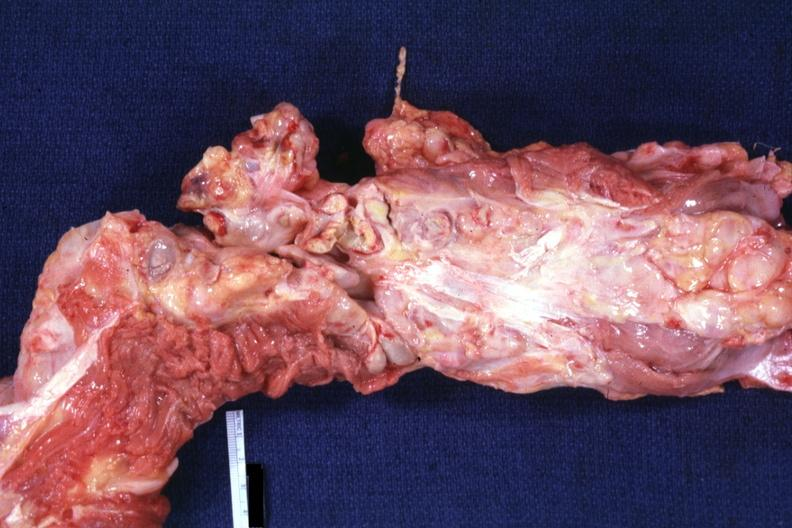s hodgkins disease present?
Answer the question using a single word or phrase. Yes 